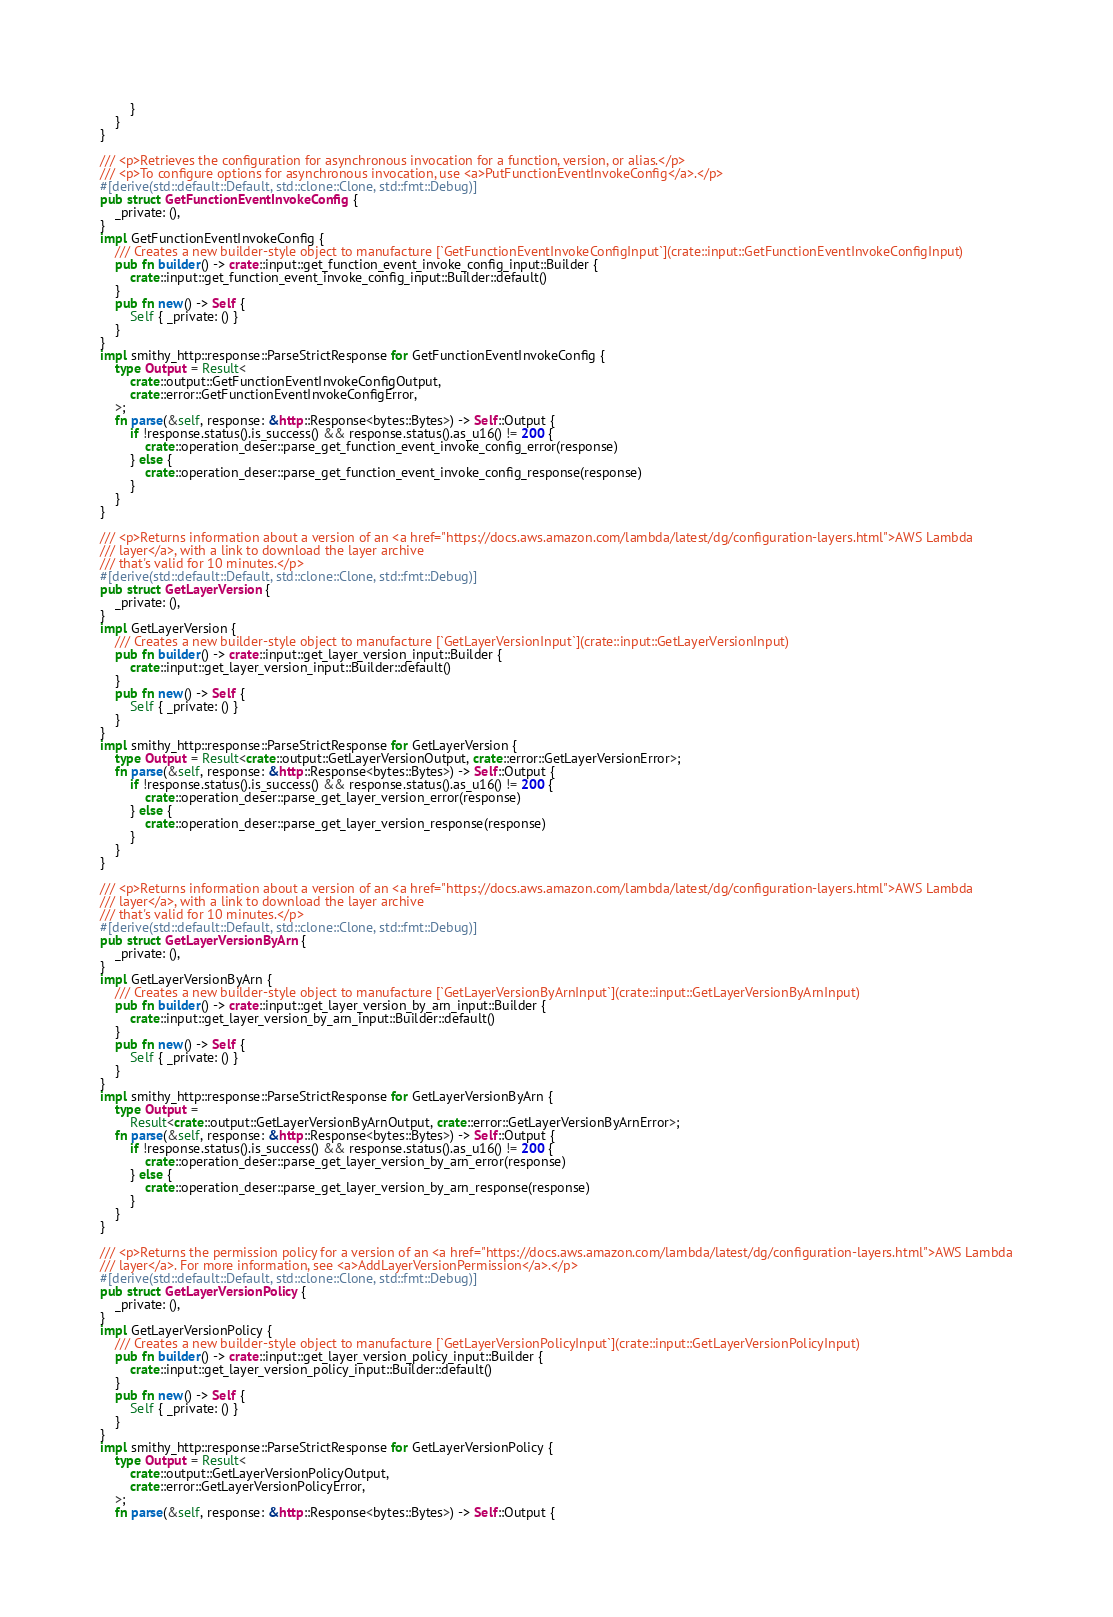<code> <loc_0><loc_0><loc_500><loc_500><_Rust_>        }
    }
}

/// <p>Retrieves the configuration for asynchronous invocation for a function, version, or alias.</p>
/// <p>To configure options for asynchronous invocation, use <a>PutFunctionEventInvokeConfig</a>.</p>
#[derive(std::default::Default, std::clone::Clone, std::fmt::Debug)]
pub struct GetFunctionEventInvokeConfig {
    _private: (),
}
impl GetFunctionEventInvokeConfig {
    /// Creates a new builder-style object to manufacture [`GetFunctionEventInvokeConfigInput`](crate::input::GetFunctionEventInvokeConfigInput)
    pub fn builder() -> crate::input::get_function_event_invoke_config_input::Builder {
        crate::input::get_function_event_invoke_config_input::Builder::default()
    }
    pub fn new() -> Self {
        Self { _private: () }
    }
}
impl smithy_http::response::ParseStrictResponse for GetFunctionEventInvokeConfig {
    type Output = Result<
        crate::output::GetFunctionEventInvokeConfigOutput,
        crate::error::GetFunctionEventInvokeConfigError,
    >;
    fn parse(&self, response: &http::Response<bytes::Bytes>) -> Self::Output {
        if !response.status().is_success() && response.status().as_u16() != 200 {
            crate::operation_deser::parse_get_function_event_invoke_config_error(response)
        } else {
            crate::operation_deser::parse_get_function_event_invoke_config_response(response)
        }
    }
}

/// <p>Returns information about a version of an <a href="https://docs.aws.amazon.com/lambda/latest/dg/configuration-layers.html">AWS Lambda
/// layer</a>, with a link to download the layer archive
/// that's valid for 10 minutes.</p>
#[derive(std::default::Default, std::clone::Clone, std::fmt::Debug)]
pub struct GetLayerVersion {
    _private: (),
}
impl GetLayerVersion {
    /// Creates a new builder-style object to manufacture [`GetLayerVersionInput`](crate::input::GetLayerVersionInput)
    pub fn builder() -> crate::input::get_layer_version_input::Builder {
        crate::input::get_layer_version_input::Builder::default()
    }
    pub fn new() -> Self {
        Self { _private: () }
    }
}
impl smithy_http::response::ParseStrictResponse for GetLayerVersion {
    type Output = Result<crate::output::GetLayerVersionOutput, crate::error::GetLayerVersionError>;
    fn parse(&self, response: &http::Response<bytes::Bytes>) -> Self::Output {
        if !response.status().is_success() && response.status().as_u16() != 200 {
            crate::operation_deser::parse_get_layer_version_error(response)
        } else {
            crate::operation_deser::parse_get_layer_version_response(response)
        }
    }
}

/// <p>Returns information about a version of an <a href="https://docs.aws.amazon.com/lambda/latest/dg/configuration-layers.html">AWS Lambda
/// layer</a>, with a link to download the layer archive
/// that's valid for 10 minutes.</p>
#[derive(std::default::Default, std::clone::Clone, std::fmt::Debug)]
pub struct GetLayerVersionByArn {
    _private: (),
}
impl GetLayerVersionByArn {
    /// Creates a new builder-style object to manufacture [`GetLayerVersionByArnInput`](crate::input::GetLayerVersionByArnInput)
    pub fn builder() -> crate::input::get_layer_version_by_arn_input::Builder {
        crate::input::get_layer_version_by_arn_input::Builder::default()
    }
    pub fn new() -> Self {
        Self { _private: () }
    }
}
impl smithy_http::response::ParseStrictResponse for GetLayerVersionByArn {
    type Output =
        Result<crate::output::GetLayerVersionByArnOutput, crate::error::GetLayerVersionByArnError>;
    fn parse(&self, response: &http::Response<bytes::Bytes>) -> Self::Output {
        if !response.status().is_success() && response.status().as_u16() != 200 {
            crate::operation_deser::parse_get_layer_version_by_arn_error(response)
        } else {
            crate::operation_deser::parse_get_layer_version_by_arn_response(response)
        }
    }
}

/// <p>Returns the permission policy for a version of an <a href="https://docs.aws.amazon.com/lambda/latest/dg/configuration-layers.html">AWS Lambda
/// layer</a>. For more information, see <a>AddLayerVersionPermission</a>.</p>
#[derive(std::default::Default, std::clone::Clone, std::fmt::Debug)]
pub struct GetLayerVersionPolicy {
    _private: (),
}
impl GetLayerVersionPolicy {
    /// Creates a new builder-style object to manufacture [`GetLayerVersionPolicyInput`](crate::input::GetLayerVersionPolicyInput)
    pub fn builder() -> crate::input::get_layer_version_policy_input::Builder {
        crate::input::get_layer_version_policy_input::Builder::default()
    }
    pub fn new() -> Self {
        Self { _private: () }
    }
}
impl smithy_http::response::ParseStrictResponse for GetLayerVersionPolicy {
    type Output = Result<
        crate::output::GetLayerVersionPolicyOutput,
        crate::error::GetLayerVersionPolicyError,
    >;
    fn parse(&self, response: &http::Response<bytes::Bytes>) -> Self::Output {</code> 